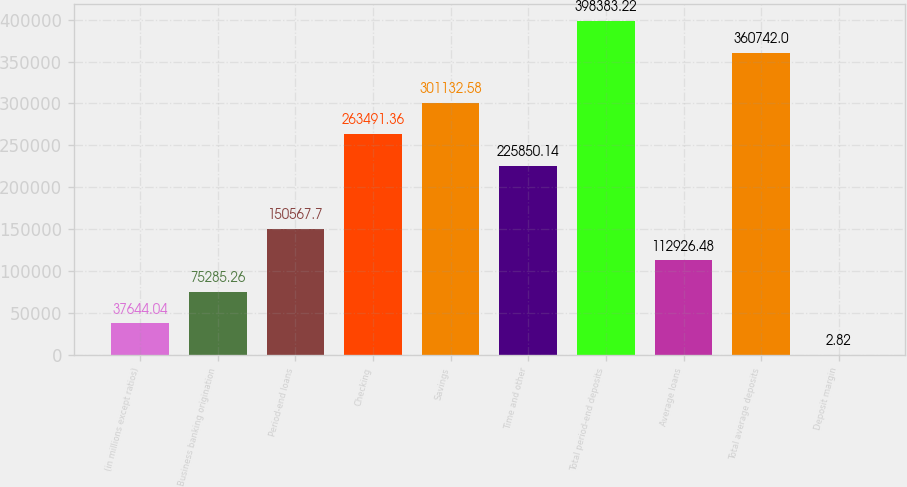Convert chart to OTSL. <chart><loc_0><loc_0><loc_500><loc_500><bar_chart><fcel>(in millions except ratios)<fcel>Business banking origination<fcel>Period-end loans<fcel>Checking<fcel>Savings<fcel>Time and other<fcel>Total period-end deposits<fcel>Average loans<fcel>Total average deposits<fcel>Deposit margin<nl><fcel>37644<fcel>75285.3<fcel>150568<fcel>263491<fcel>301133<fcel>225850<fcel>398383<fcel>112926<fcel>360742<fcel>2.82<nl></chart> 